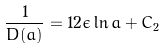<formula> <loc_0><loc_0><loc_500><loc_500>\frac { 1 } { D ( a ) } = 1 2 \epsilon \ln a + C _ { 2 } \\</formula> 